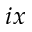<formula> <loc_0><loc_0><loc_500><loc_500>i x</formula> 